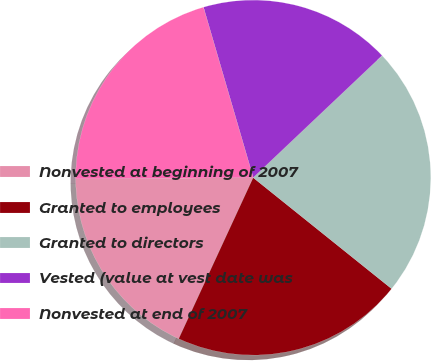Convert chart. <chart><loc_0><loc_0><loc_500><loc_500><pie_chart><fcel>Nonvested at beginning of 2007<fcel>Granted to employees<fcel>Granted to directors<fcel>Vested (value at vest date was<fcel>Nonvested at end of 2007<nl><fcel>18.0%<fcel>21.13%<fcel>22.83%<fcel>17.46%<fcel>20.59%<nl></chart> 